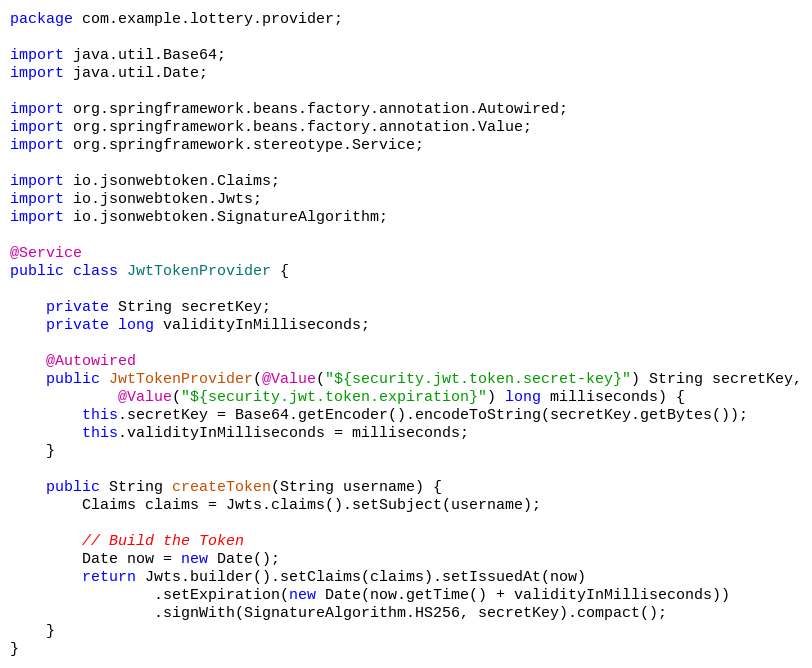<code> <loc_0><loc_0><loc_500><loc_500><_Java_>package com.example.lottery.provider;

import java.util.Base64;
import java.util.Date;

import org.springframework.beans.factory.annotation.Autowired;
import org.springframework.beans.factory.annotation.Value;
import org.springframework.stereotype.Service;

import io.jsonwebtoken.Claims;
import io.jsonwebtoken.Jwts;
import io.jsonwebtoken.SignatureAlgorithm;

@Service
public class JwtTokenProvider {

	private String secretKey;
	private long validityInMilliseconds;

	@Autowired
	public JwtTokenProvider(@Value("${security.jwt.token.secret-key}") String secretKey,
			@Value("${security.jwt.token.expiration}") long milliseconds) {
		this.secretKey = Base64.getEncoder().encodeToString(secretKey.getBytes());
		this.validityInMilliseconds = milliseconds;
	}

	public String createToken(String username) {
		Claims claims = Jwts.claims().setSubject(username);

		// Build the Token
		Date now = new Date();
		return Jwts.builder().setClaims(claims).setIssuedAt(now)
				.setExpiration(new Date(now.getTime() + validityInMilliseconds))
				.signWith(SignatureAlgorithm.HS256, secretKey).compact();
	}
}</code> 